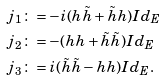<formula> <loc_0><loc_0><loc_500><loc_500>j _ { 1 } & \colon = - i ( h \tilde { h } + \tilde { h } h ) I d _ { E } \\ j _ { 2 } & \colon = - ( h h + \tilde { h } \tilde { h } ) I d _ { E } \\ j _ { 3 } & \colon = i ( \tilde { h } \tilde { h } - h h ) I d _ { E } .</formula> 